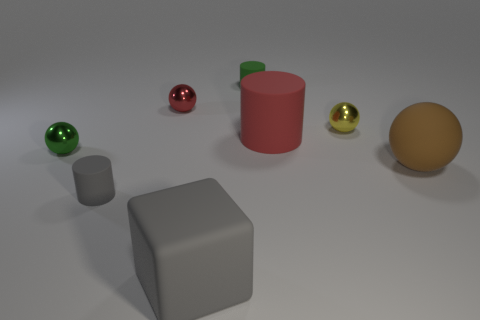The small metal thing that is on the left side of the cylinder in front of the green thing on the left side of the tiny red object is what shape?
Provide a short and direct response. Sphere. There is a sphere that is on the left side of the small red metallic object; what is it made of?
Provide a short and direct response. Metal. What is the color of the rubber cylinder that is the same size as the gray cube?
Your response must be concise. Red. What number of other objects are the same shape as the small green metal thing?
Keep it short and to the point. 3. Do the red sphere and the yellow ball have the same size?
Your answer should be compact. Yes. Is the number of tiny objects that are right of the big gray object greater than the number of brown matte things left of the large brown matte object?
Ensure brevity in your answer.  Yes. What number of other things are the same size as the green rubber thing?
Give a very brief answer. 4. Is the color of the ball in front of the green shiny thing the same as the large cylinder?
Keep it short and to the point. No. Is the number of large spheres that are on the left side of the green rubber cylinder greater than the number of tiny brown objects?
Provide a short and direct response. No. Is there anything else of the same color as the rubber block?
Offer a very short reply. Yes. 